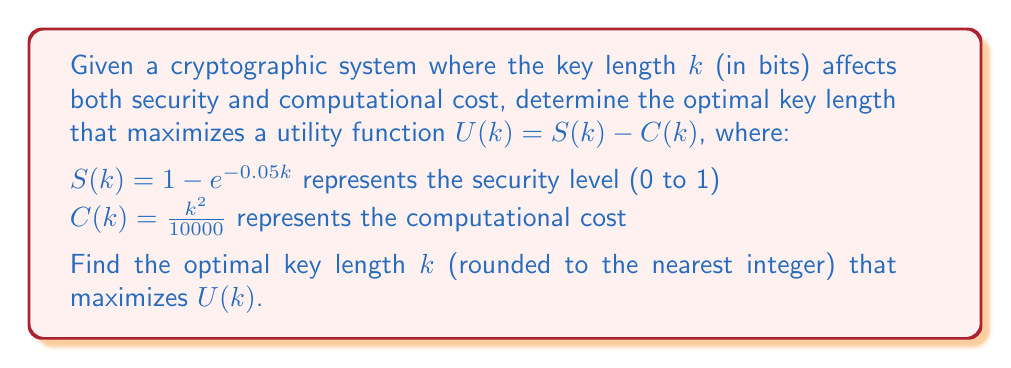Show me your answer to this math problem. To find the optimal key length, we need to maximize the utility function $U(k)$. This can be done by finding the value of $k$ where the derivative of $U(k)$ equals zero.

1) First, let's express $U(k)$:
   $$U(k) = S(k) - C(k) = (1 - e^{-0.05k}) - \frac{k^2}{10000}$$

2) Now, let's find the derivative $U'(k)$:
   $$U'(k) = 0.05e^{-0.05k} - \frac{2k}{10000}$$

3) Set $U'(k) = 0$ and solve for $k$:
   $$0.05e^{-0.05k} - \frac{2k}{10000} = 0$$
   $$0.05e^{-0.05k} = \frac{2k}{10000}$$
   $$250e^{-0.05k} = k$$

4) This equation cannot be solved analytically. We need to use numerical methods, such as Newton's method, to find the solution.

5) Using Newton's method or a computer algebra system, we find that the solution is approximately $k \approx 93.2439$.

6) Rounding to the nearest integer gives us $k = 93$.

7) To verify this is a maximum, we can check the second derivative is negative at this point or evaluate $U(k)$ for nearby values of $k$.
Answer: 93 bits 